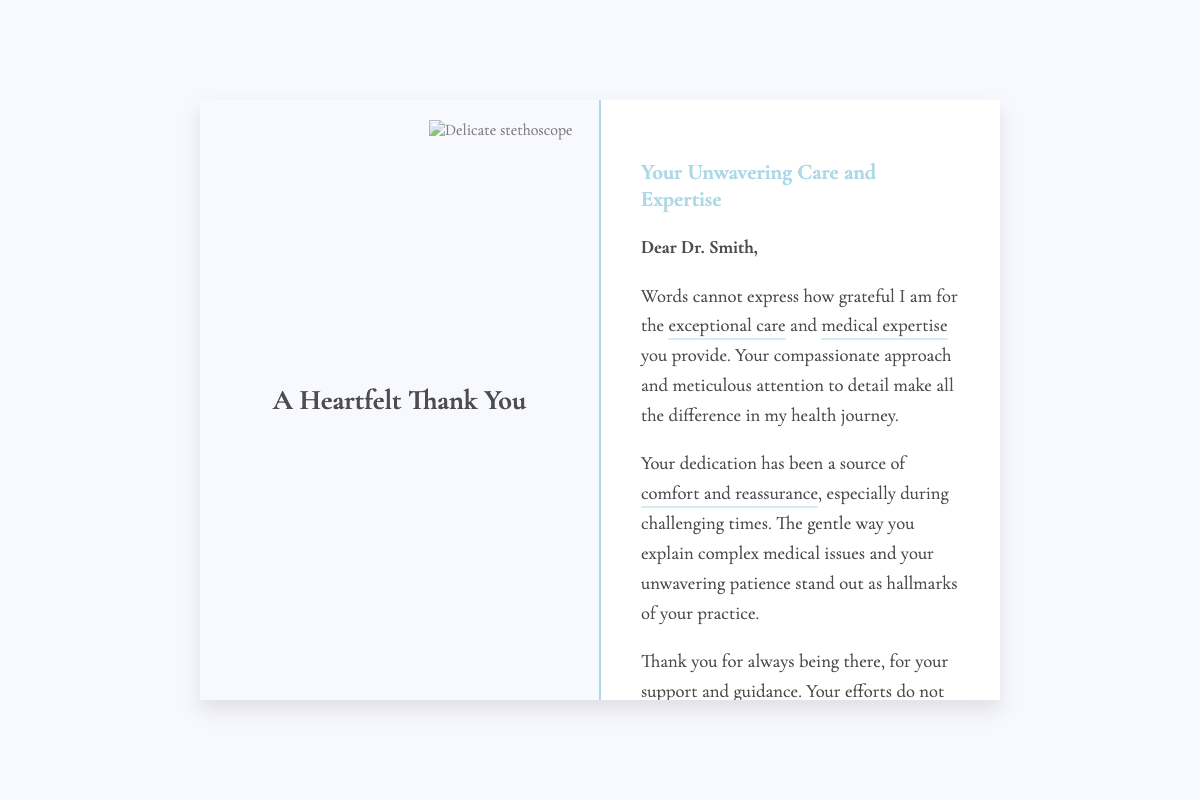What is the title of the card? The title of the card is prominently displayed at the top of the front cover of the document.
Answer: A Heartfelt Thank You Who is the recipient of the card? The recipient's name is mentioned at the beginning of the inside page, indicating to whom the card is addressed.
Answer: Dr. Smith What colors are primarily used in the card's design? The colors in the design include soothing, gentle colors visible in the background and text, creating a comforting appearance.
Answer: Gentle colors What is expressed as the recipient's main quality in the message? The message highlights the recipient's characteristics that stand out to the sender, which is a crucial element of appreciation.
Answer: Compassionate approach What does the sender thank Dr. Smith for specifically? The text mentions various reasons for gratitude, summarizing the main aspects of care and support received by the sender.
Answer: Support and guidance What aspect of the recipient's communication style is emphasized? The sender appreciates a specific part of how Dr. Smith communicates detailed medical information.
Answer: Gentle explanation How is the tone of the card described? The card's tone is reflected in the sentiments conveyed throughout the content, influencing how the message is perceived.
Answer: Heartfelt What is the closing sign-off in the card? The final lines of the inside page reveal how the card concludes, signifying the sender's respect and gratitude.
Answer: With sincere gratitude, John Doe 